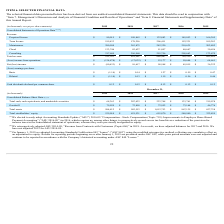From Pegasystems's financial document, What are the respective revenue from perpetual license in 2015 and 2016? The document shows two values: 166,305 and 145,053 (in thousands). From the document: "Perpetual license $ 80,015 $ 109,863 $ 132,883 $ 145,053 $ 166,305 license $ 80,015 $ 109,863 $ 132,883 $ 145,053 $ 166,305..." Also, What are the respective revenue from perpetual license in 2016 and 2017? The document shows two values: 145,053 and 132,883 (in thousands). From the document: "Perpetual license $ 80,015 $ 109,863 $ 132,883 $ 145,053 $ 166,305 Perpetual license $ 80,015 $ 109,863 $ 132,883 $ 145,053 $ 166,305..." Also, What are the respective revenue from perpetual license in 2018 and 2019? The document shows two values: 109,863 and 80,015 (in thousands). From the document: "Perpetual license $ 80,015 $ 109,863 $ 132,883 $ 145,053 $ 166,305 Perpetual license $ 80,015 $ 109,863 $ 132,883 $ 145,053 $ 166,305..." Also, can you calculate: What is the percentage change in the revenue earned from term license between 2015 and 2016? To answer this question, I need to perform calculations using the financial data. The calculation is: (152,231 - 109,283)/109,283 , which equals 39.3 (percentage). This is based on the information: "Term license 199,433 178,256 206,411 152,231 109,283 Term license 199,433 178,256 206,411 152,231 109,283..." The key data points involved are: 109,283, 152,231. Also, can you calculate: What is the percentage change in the revenue earned from perpetual license between 2018 and 2019? To answer this question, I need to perform calculations using the financial data. The calculation is: (80,015 - 109,863)/109,863 , which equals -27.17 (percentage). This is based on the information: "Perpetual license $ 80,015 $ 109,863 $ 132,883 $ 145,053 $ 166,305 Perpetual license $ 80,015 $ 109,863 $ 132,883 $ 145,053 $ 166,305..." The key data points involved are: 109,863, 80,015. Also, can you calculate: What is the total revenue earned from maintenance in 2017 and 2018? Based on the calculation: 242,320 + 263,875 , the result is 506195 (in thousands). This is based on the information: "Maintenance 280,580 263,875 242,320 218,635 202,802 Maintenance 280,580 263,875 242,320 218,635 202,802..." The key data points involved are: 242,320, 263,875. 